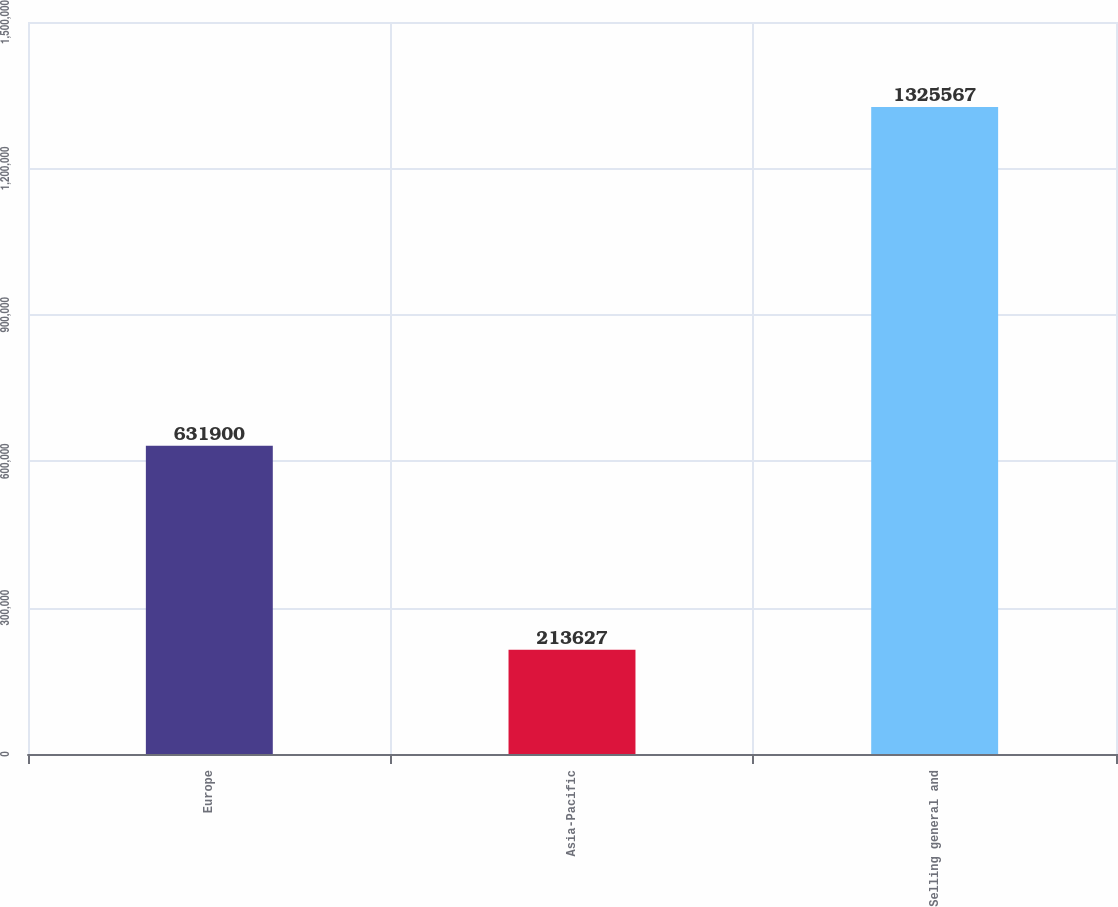Convert chart to OTSL. <chart><loc_0><loc_0><loc_500><loc_500><bar_chart><fcel>Europe<fcel>Asia-Pacific<fcel>Selling general and<nl><fcel>631900<fcel>213627<fcel>1.32557e+06<nl></chart> 